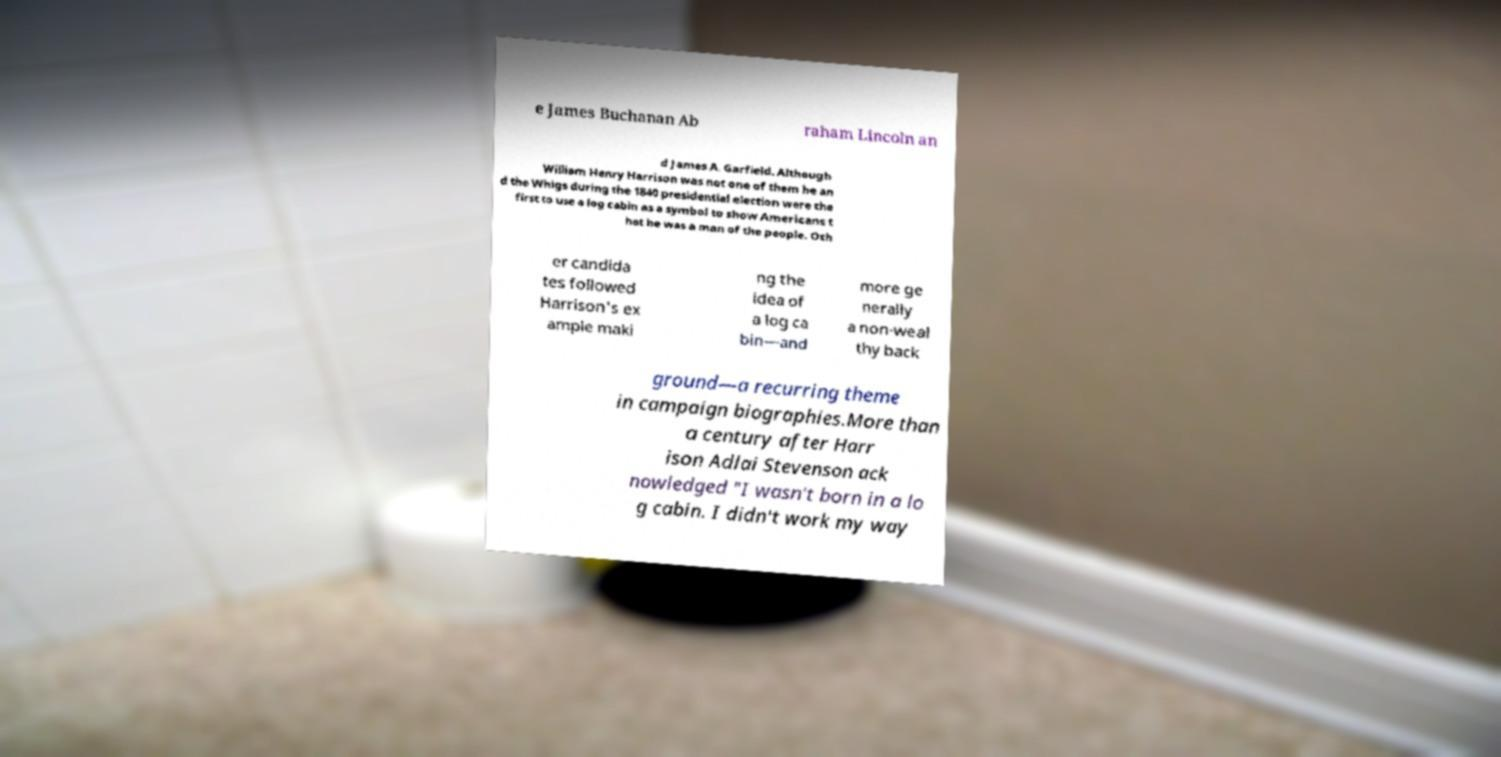Please read and relay the text visible in this image. What does it say? e James Buchanan Ab raham Lincoln an d James A. Garfield. Although William Henry Harrison was not one of them he an d the Whigs during the 1840 presidential election were the first to use a log cabin as a symbol to show Americans t hat he was a man of the people. Oth er candida tes followed Harrison's ex ample maki ng the idea of a log ca bin—and more ge nerally a non-weal thy back ground—a recurring theme in campaign biographies.More than a century after Harr ison Adlai Stevenson ack nowledged "I wasn't born in a lo g cabin. I didn't work my way 